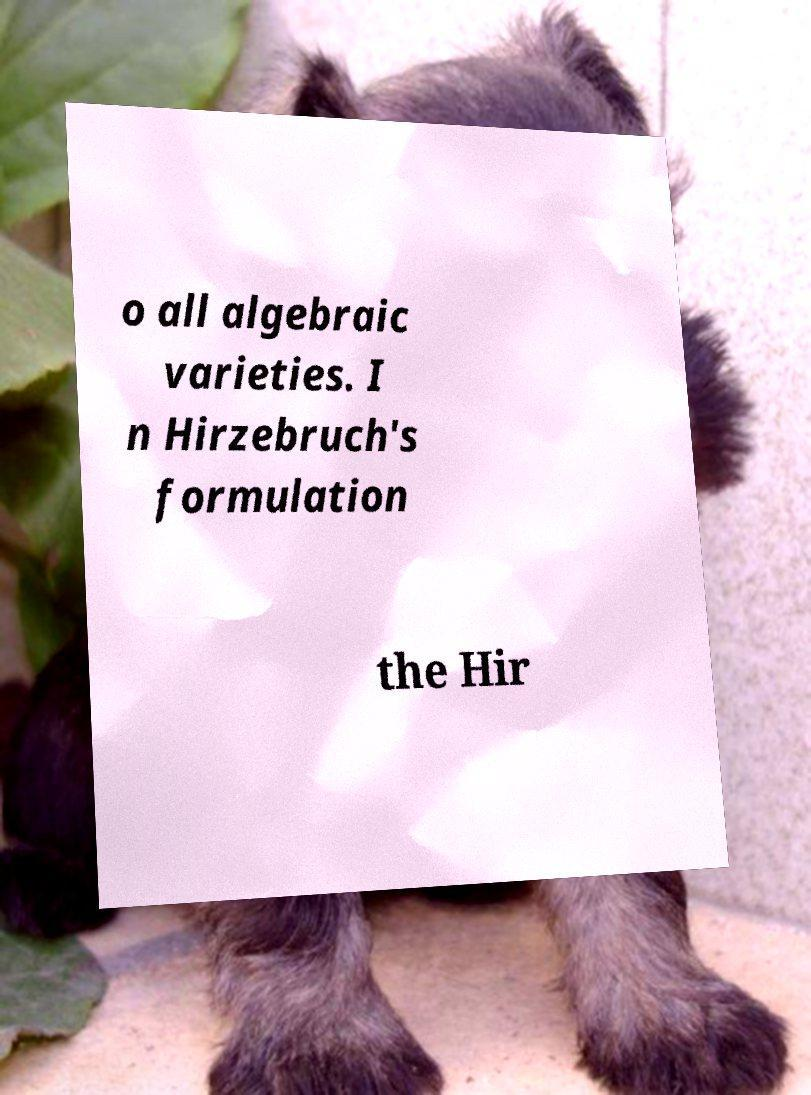Please identify and transcribe the text found in this image. o all algebraic varieties. I n Hirzebruch's formulation the Hir 